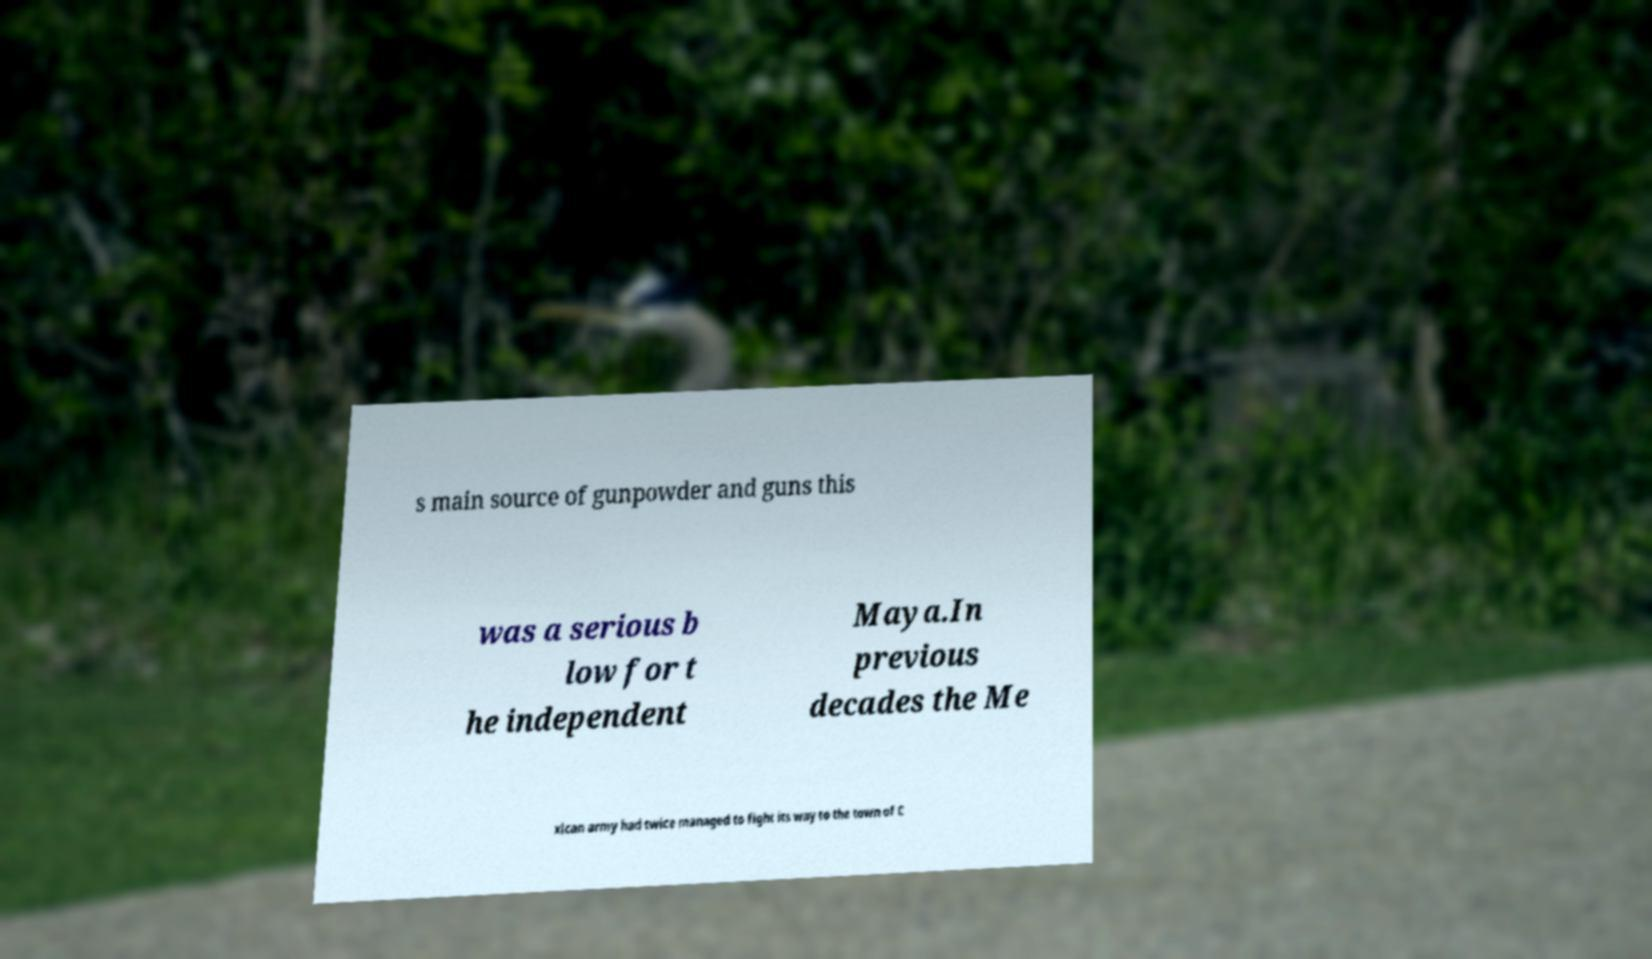Can you accurately transcribe the text from the provided image for me? s main source of gunpowder and guns this was a serious b low for t he independent Maya.In previous decades the Me xican army had twice managed to fight its way to the town of C 